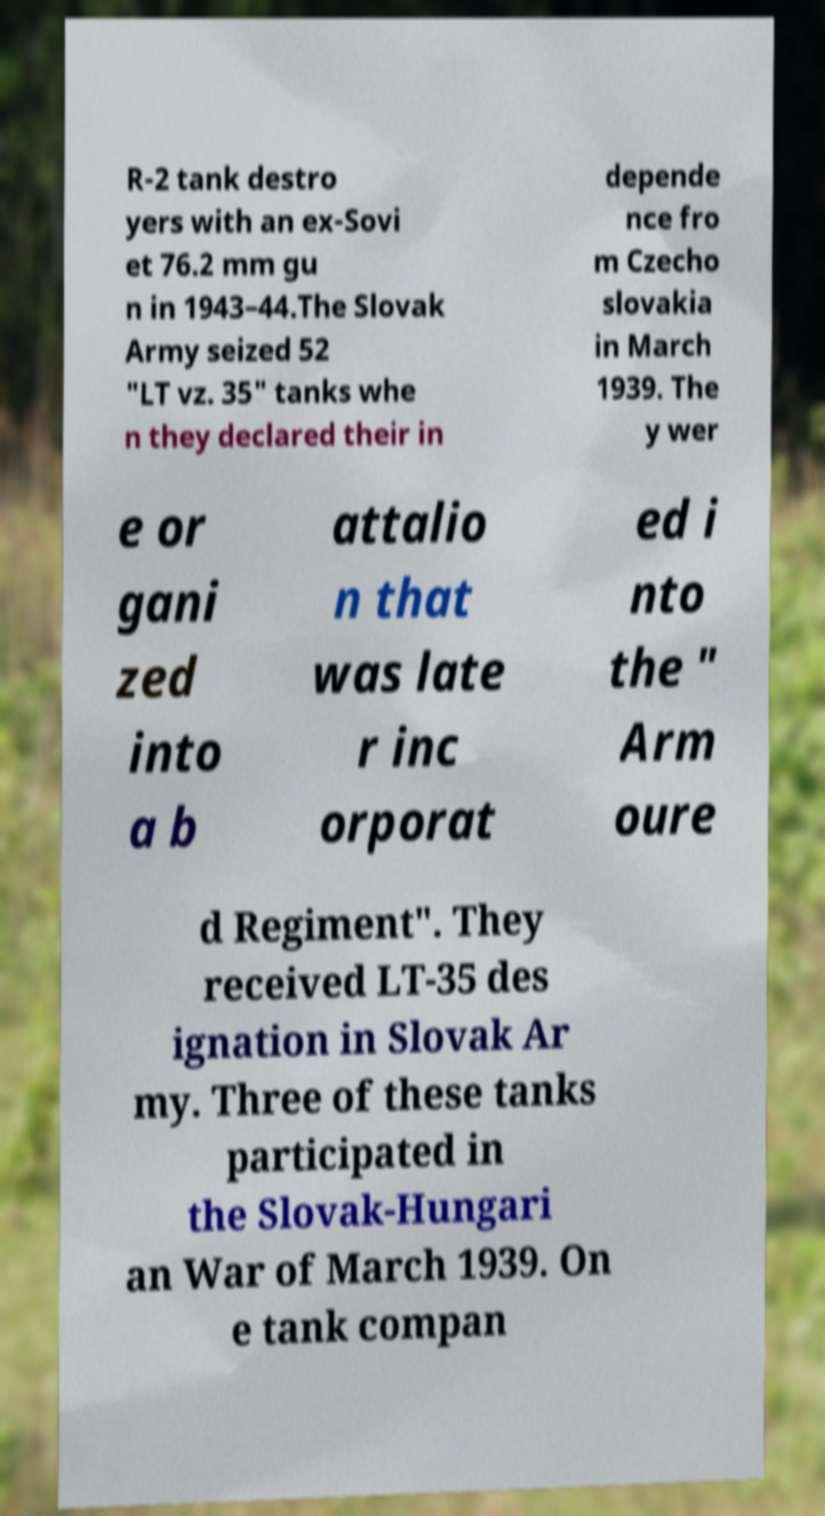Could you extract and type out the text from this image? R-2 tank destro yers with an ex-Sovi et 76.2 mm gu n in 1943–44.The Slovak Army seized 52 "LT vz. 35" tanks whe n they declared their in depende nce fro m Czecho slovakia in March 1939. The y wer e or gani zed into a b attalio n that was late r inc orporat ed i nto the " Arm oure d Regiment". They received LT-35 des ignation in Slovak Ar my. Three of these tanks participated in the Slovak-Hungari an War of March 1939. On e tank compan 